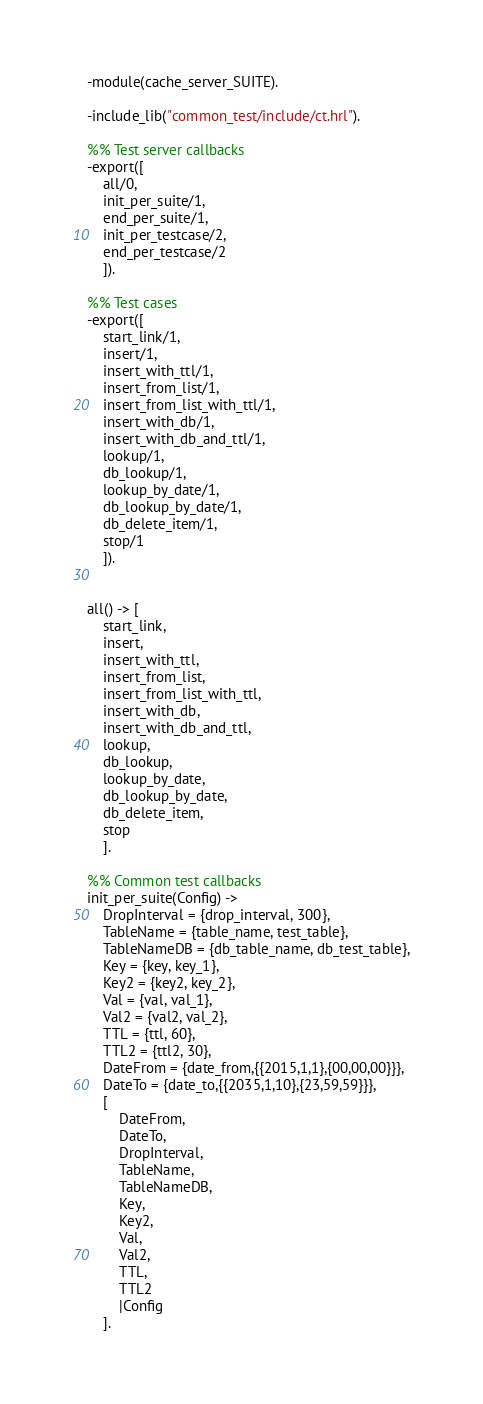Convert code to text. <code><loc_0><loc_0><loc_500><loc_500><_Erlang_>-module(cache_server_SUITE).

-include_lib("common_test/include/ct.hrl").

%% Test server callbacks
-export([
    all/0,
    init_per_suite/1, 
    end_per_suite/1,
    init_per_testcase/2, 
    end_per_testcase/2
    ]).

%% Test cases
-export([
    start_link/1,
    insert/1,
    insert_with_ttl/1,
    insert_from_list/1,
    insert_from_list_with_ttl/1,
    insert_with_db/1,
    insert_with_db_and_ttl/1,
    lookup/1,
    db_lookup/1,
    lookup_by_date/1,
    db_lookup_by_date/1,
    db_delete_item/1,
    stop/1
    ]).


all() -> [
    start_link, 
    insert,
    insert_with_ttl,
    insert_from_list,
    insert_from_list_with_ttl,
    insert_with_db,
    insert_with_db_and_ttl,
    lookup,
    db_lookup,
    lookup_by_date,
    db_lookup_by_date,
    db_delete_item,
    stop
    ].

%% Common test callbacks
init_per_suite(Config) ->
    DropInterval = {drop_interval, 300},
    TableName = {table_name, test_table},
    TableNameDB = {db_table_name, db_test_table},
    Key = {key, key_1},
    Key2 = {key2, key_2},
    Val = {val, val_1},
    Val2 = {val2, val_2},
    TTL = {ttl, 60},
    TTL2 = {ttl2, 30},
    DateFrom = {date_from,{{2015,1,1},{00,00,00}}},
    DateTo = {date_to,{{2035,1,10},{23,59,59}}},
    [
        DateFrom, 
        DateTo, 
        DropInterval, 
        TableName, 
        TableNameDB, 
        Key, 
        Key2, 
        Val, 
        Val2, 
        TTL, 
        TTL2
        |Config
    ].
</code> 